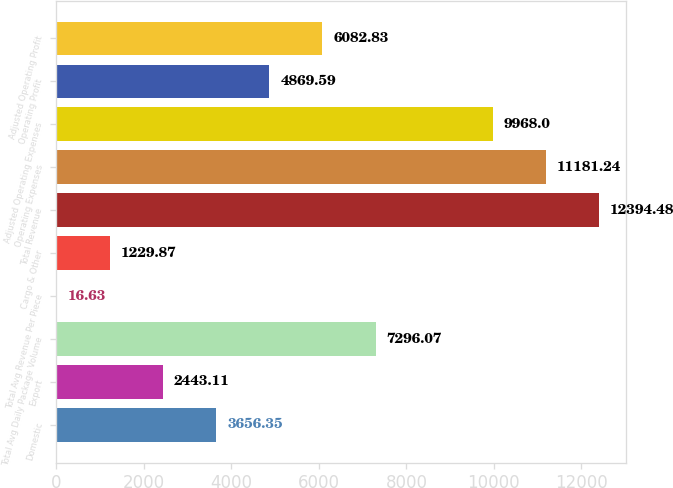Convert chart. <chart><loc_0><loc_0><loc_500><loc_500><bar_chart><fcel>Domestic<fcel>Export<fcel>Total Avg Daily Package Volume<fcel>Total Avg Revenue Per Piece<fcel>Cargo & Other<fcel>Total Revenue<fcel>Operating Expenses<fcel>Adjusted Operating Expenses<fcel>Operating Profit<fcel>Adjusted Operating Profit<nl><fcel>3656.35<fcel>2443.11<fcel>7296.07<fcel>16.63<fcel>1229.87<fcel>12394.5<fcel>11181.2<fcel>9968<fcel>4869.59<fcel>6082.83<nl></chart> 